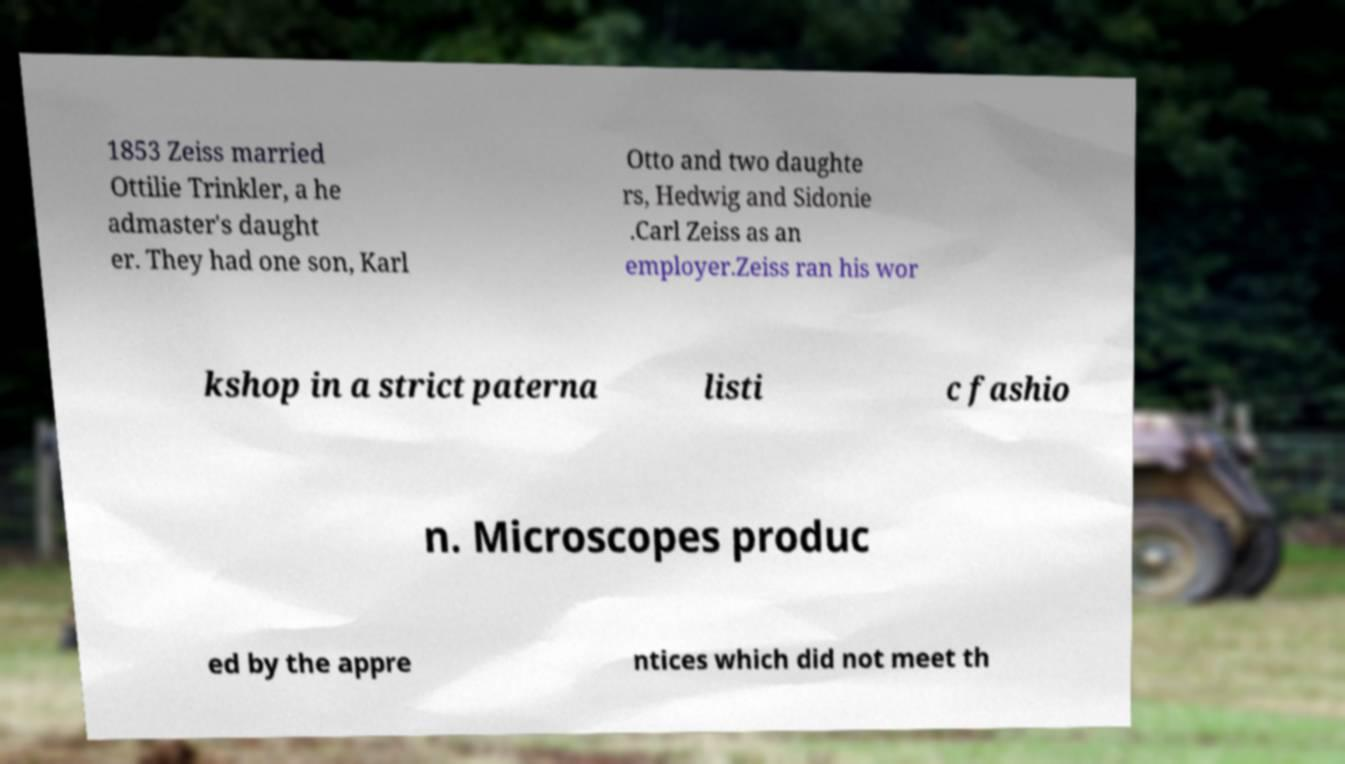Please read and relay the text visible in this image. What does it say? 1853 Zeiss married Ottilie Trinkler, a he admaster's daught er. They had one son, Karl Otto and two daughte rs, Hedwig and Sidonie .Carl Zeiss as an employer.Zeiss ran his wor kshop in a strict paterna listi c fashio n. Microscopes produc ed by the appre ntices which did not meet th 